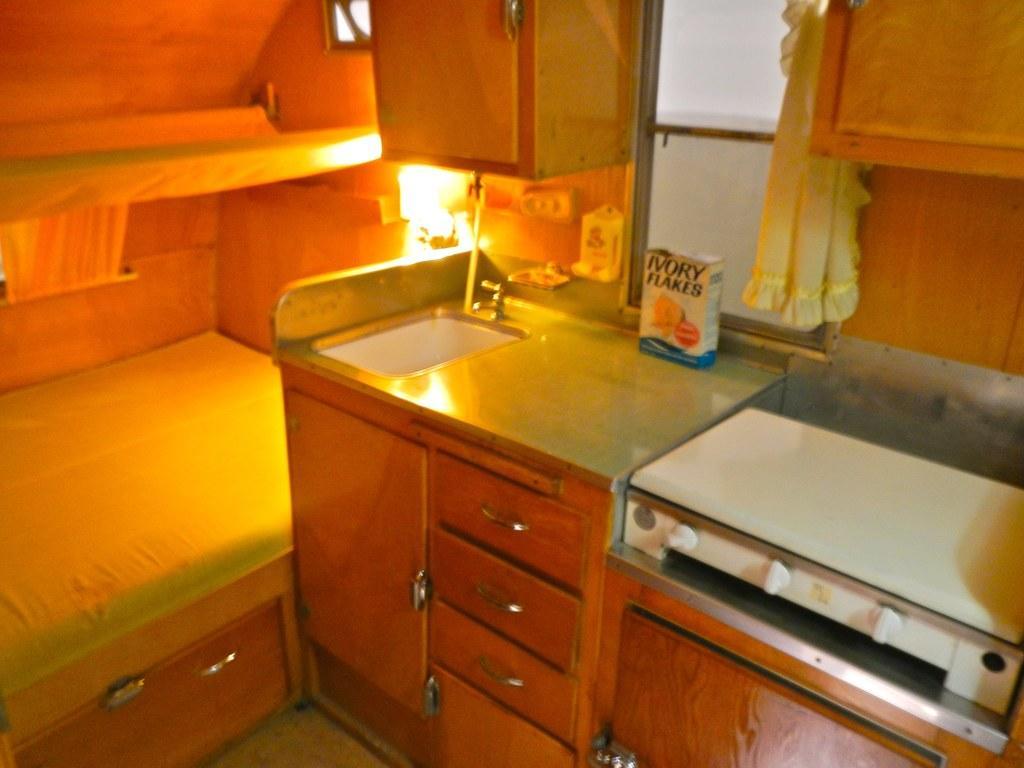Could you give a brief overview of what you see in this image? In the picture we can see a bedroom along with the table near to it on the table there are different items,a gas stove and a light and a cup board there is a window near to the wall there is a curtain. 